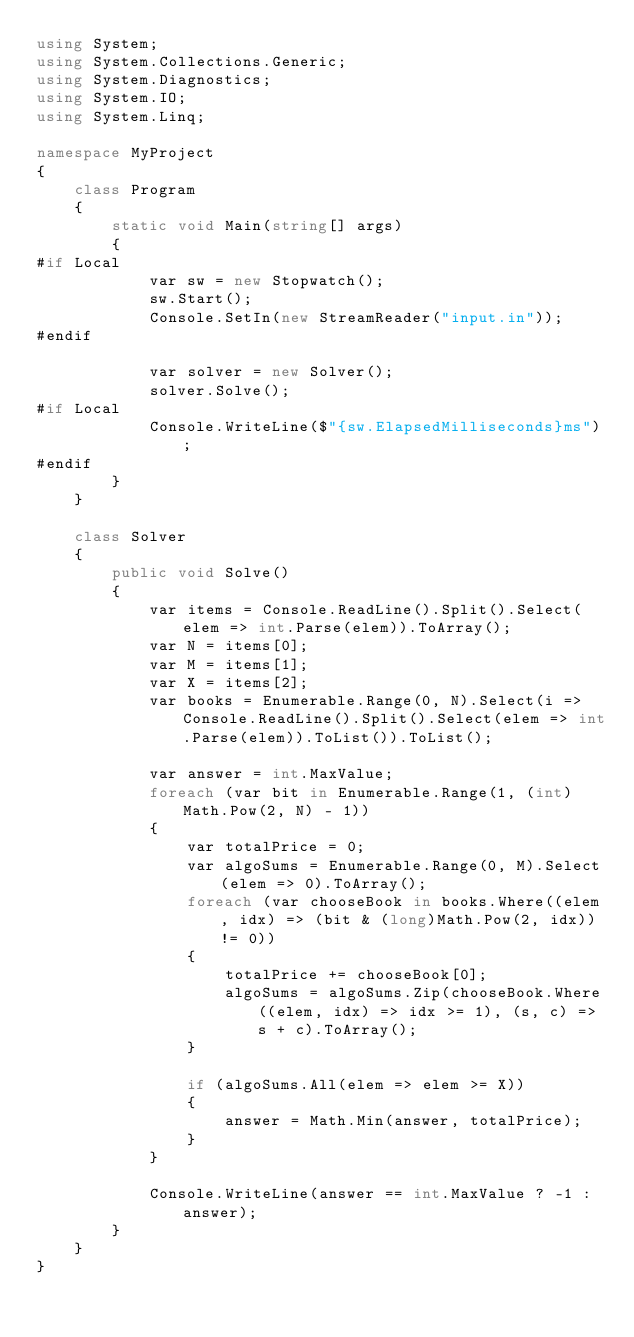Convert code to text. <code><loc_0><loc_0><loc_500><loc_500><_C#_>using System;
using System.Collections.Generic;
using System.Diagnostics;
using System.IO;
using System.Linq;

namespace MyProject
{
    class Program
    {
        static void Main(string[] args)
        {
#if Local
            var sw = new Stopwatch();
            sw.Start();
            Console.SetIn(new StreamReader("input.in"));
#endif

            var solver = new Solver();
            solver.Solve();
#if Local
            Console.WriteLine($"{sw.ElapsedMilliseconds}ms");
#endif
        }
    }

    class Solver
    {
        public void Solve()
        {
            var items = Console.ReadLine().Split().Select(elem => int.Parse(elem)).ToArray();
            var N = items[0];
            var M = items[1];
            var X = items[2];
            var books = Enumerable.Range(0, N).Select(i => Console.ReadLine().Split().Select(elem => int.Parse(elem)).ToList()).ToList();

            var answer = int.MaxValue;
            foreach (var bit in Enumerable.Range(1, (int)Math.Pow(2, N) - 1))
            {
                var totalPrice = 0;
                var algoSums = Enumerable.Range(0, M).Select(elem => 0).ToArray();
                foreach (var chooseBook in books.Where((elem, idx) => (bit & (long)Math.Pow(2, idx)) != 0))
                {
                    totalPrice += chooseBook[0];
                    algoSums = algoSums.Zip(chooseBook.Where((elem, idx) => idx >= 1), (s, c) => s + c).ToArray();
                }

                if (algoSums.All(elem => elem >= X))
                {
                    answer = Math.Min(answer, totalPrice);
                }
            }

            Console.WriteLine(answer == int.MaxValue ? -1 : answer);
        }
    }
}
</code> 